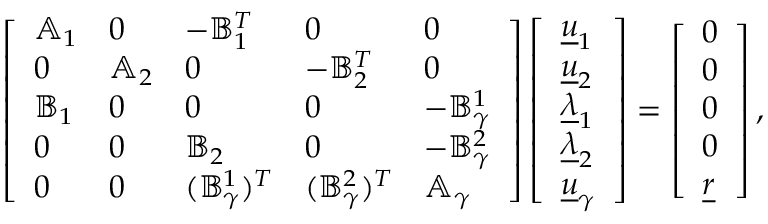<formula> <loc_0><loc_0><loc_500><loc_500>\left [ \begin{array} { l l l l l } { \mathbb { A } _ { 1 } } & { 0 } & { - \mathbb { B } _ { 1 } ^ { T } } & { 0 } & { 0 } \\ { 0 } & { \mathbb { A } _ { 2 } } & { 0 } & { - \mathbb { B } _ { 2 } ^ { T } } & { 0 } \\ { \mathbb { B } _ { 1 } } & { 0 } & { 0 } & { 0 } & { - \mathbb { B } _ { \gamma } ^ { 1 } } \\ { 0 } & { 0 } & { \mathbb { B } _ { 2 } } & { 0 } & { - \mathbb { B } _ { \gamma } ^ { 2 } } \\ { 0 } & { 0 } & { ( \mathbb { B } _ { \gamma } ^ { 1 } ) ^ { T } } & { ( \mathbb { B } _ { \gamma } ^ { 2 } ) ^ { T } } & { \mathbb { A } _ { \gamma } } \end{array} \right ] \left [ \begin{array} { l } { \underline { u } _ { 1 } } \\ { \underline { u } _ { 2 } } \\ { \underline { \lambda } _ { 1 } } \\ { \underline { \lambda } _ { 2 } } \\ { \underline { u } _ { \gamma } } \end{array} \right ] = \left [ \begin{array} { l } { 0 } \\ { 0 } \\ { 0 } \\ { 0 } \\ { \underline { r } } \end{array} \right ] ,</formula> 